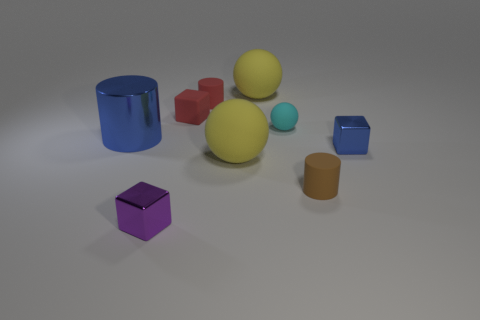What number of large things are either red matte blocks or yellow things?
Give a very brief answer. 2. Are there fewer large yellow things behind the blue cylinder than tiny things to the right of the tiny brown object?
Make the answer very short. No. What number of objects are either small matte things or blue matte objects?
Give a very brief answer. 4. There is a red cube; what number of small shiny things are right of it?
Keep it short and to the point. 1. What is the shape of the cyan object that is the same material as the small brown cylinder?
Your answer should be compact. Sphere. There is a object that is in front of the small brown matte object; is it the same shape as the large blue metal object?
Ensure brevity in your answer.  No. What number of cyan things are small matte balls or big rubber objects?
Your answer should be very brief. 1. Are there the same number of purple metal cubes that are behind the large blue metallic object and small purple metal objects on the right side of the tiny purple metallic object?
Provide a short and direct response. Yes. What color is the small metallic block on the right side of the cylinder to the right of the large yellow rubber object in front of the big blue metallic cylinder?
Give a very brief answer. Blue. Are there any other things of the same color as the tiny rubber block?
Make the answer very short. Yes. 